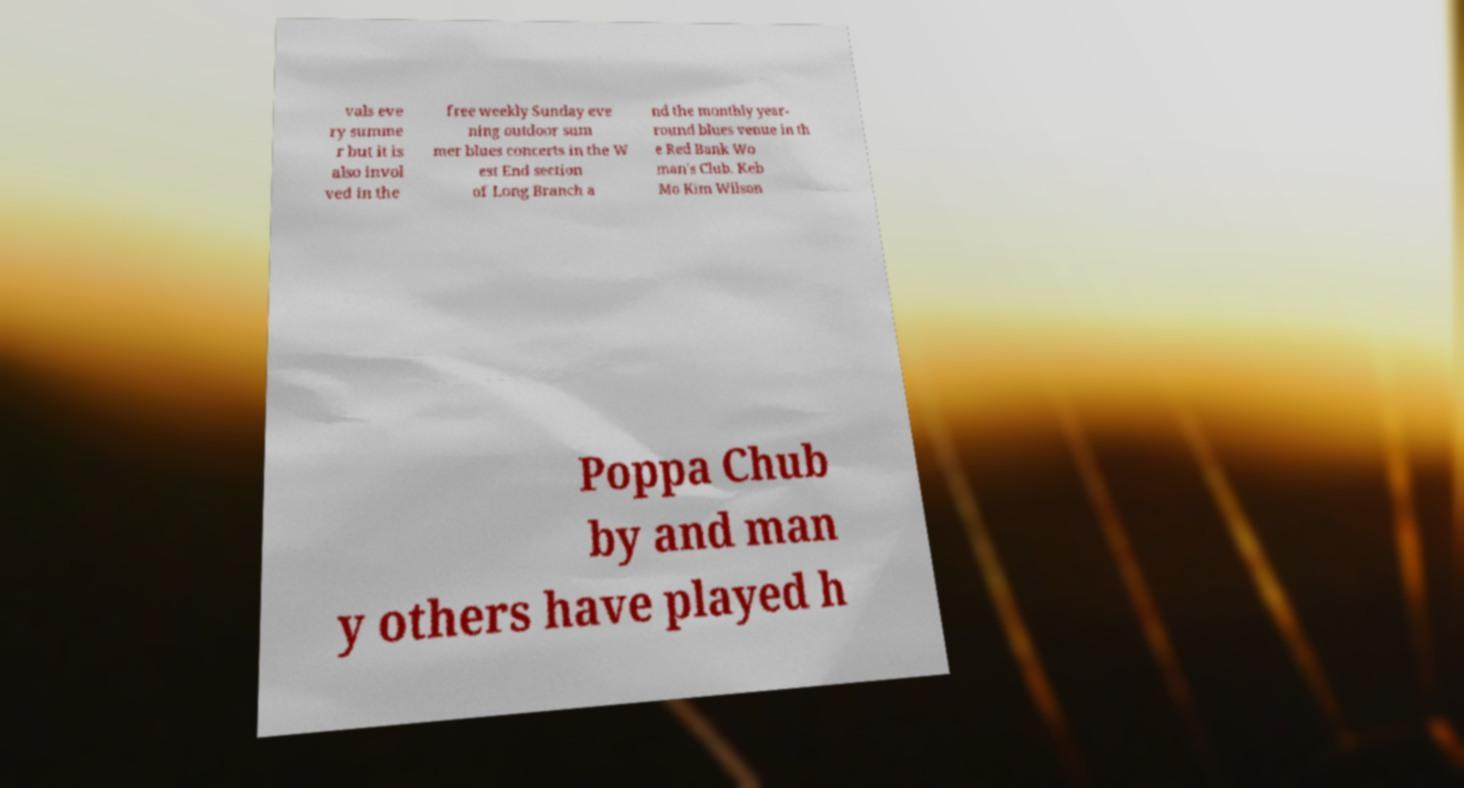Could you assist in decoding the text presented in this image and type it out clearly? vals eve ry summe r but it is also invol ved in the free weekly Sunday eve ning outdoor sum mer blues concerts in the W est End section of Long Branch a nd the monthly year- round blues venue in th e Red Bank Wo man's Club. Keb Mo Kim Wilson Poppa Chub by and man y others have played h 